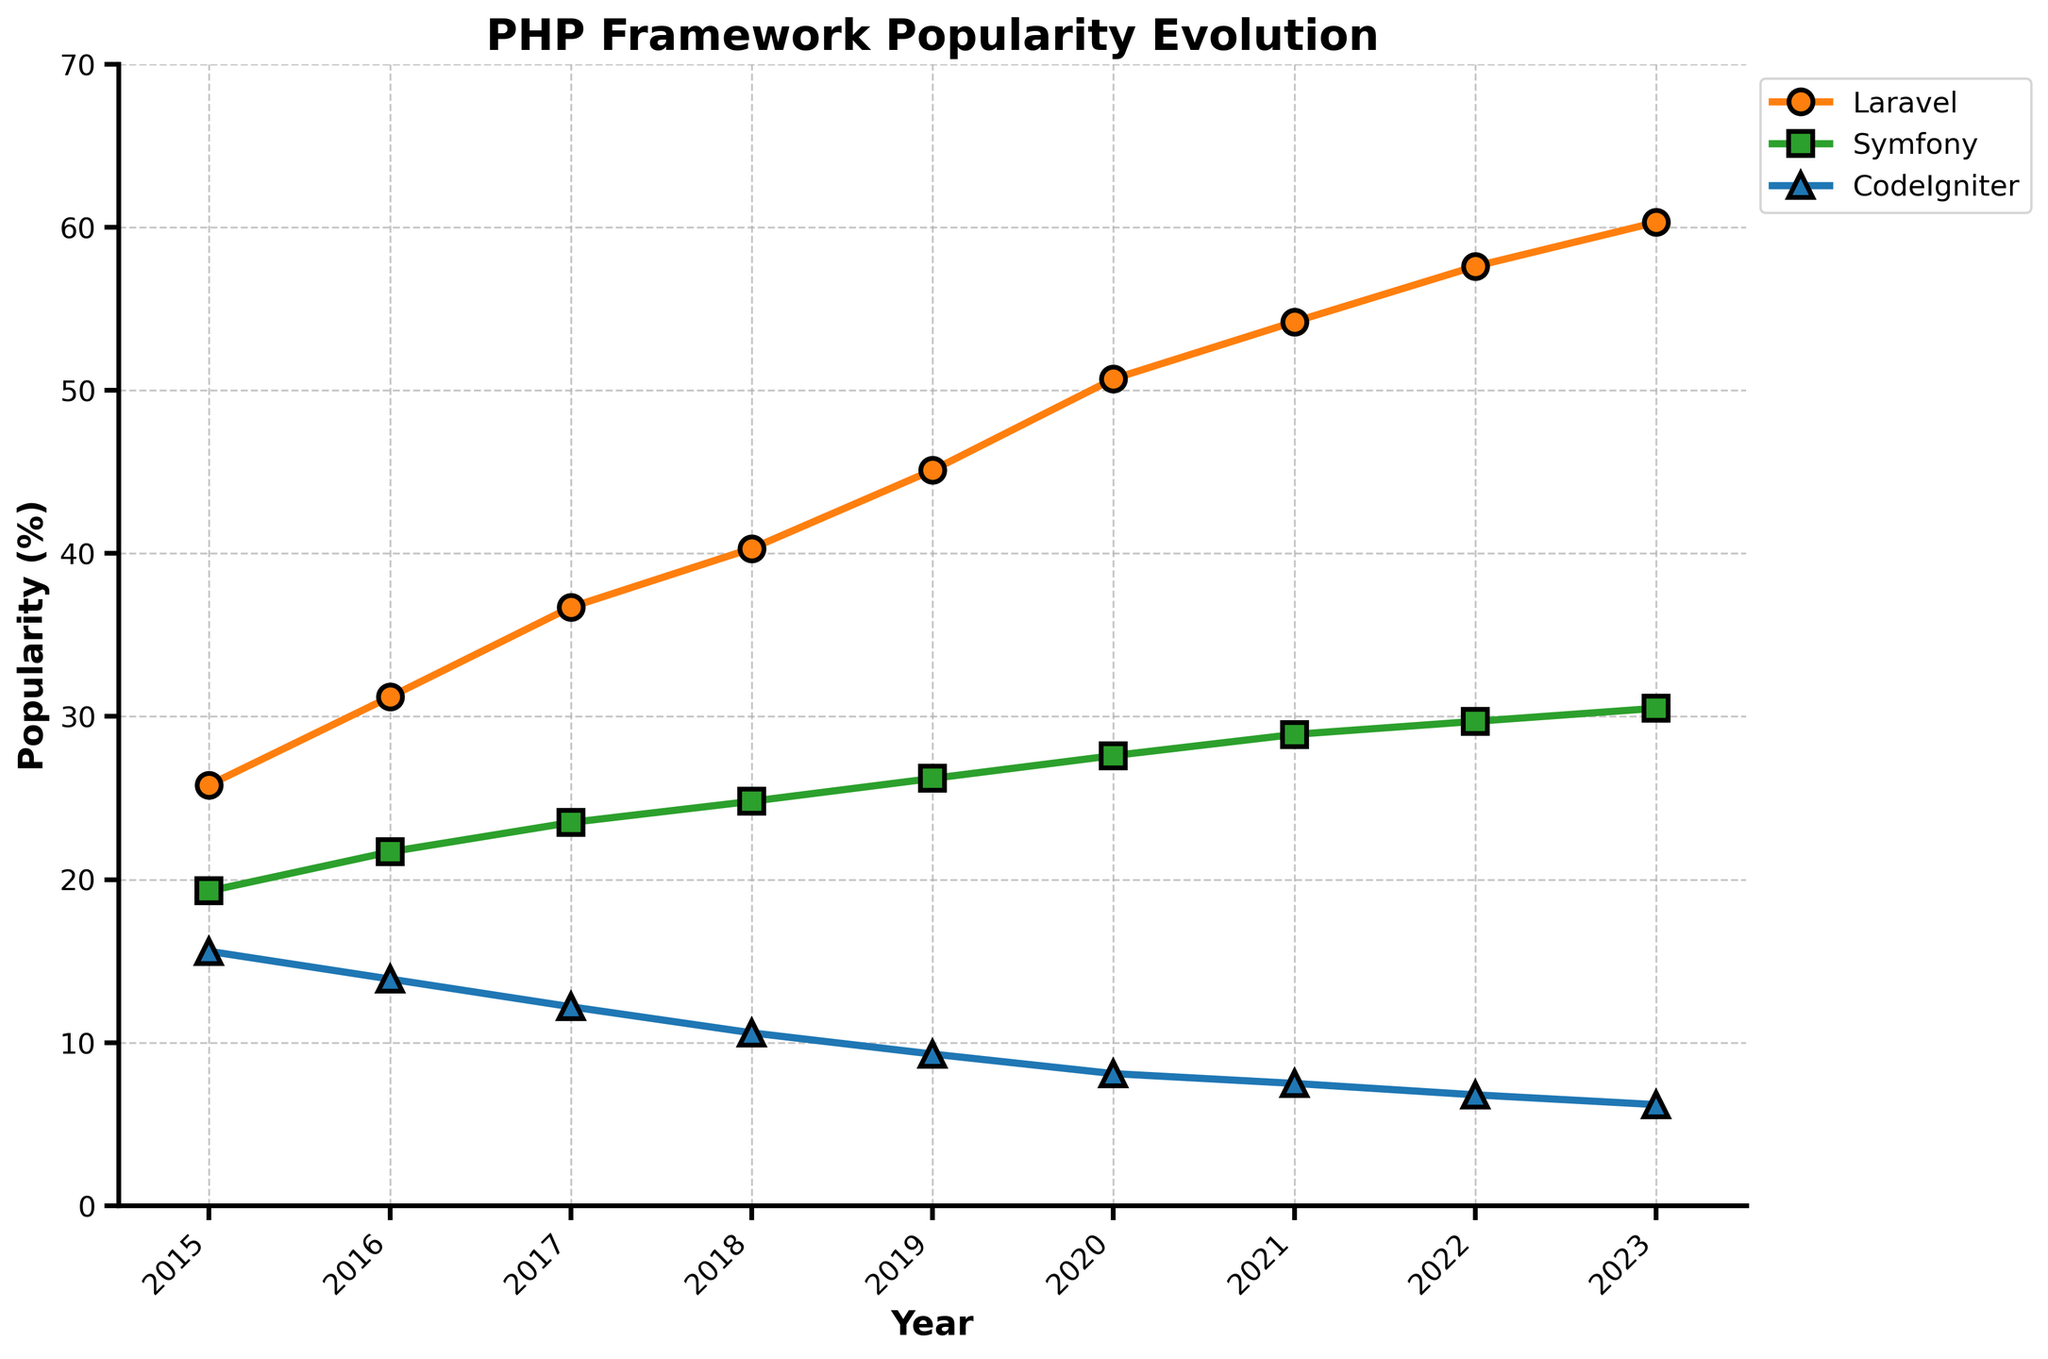What year did Laravel first surpass 50% popularity? By looking at the line representing Laravel (orange with circle markers), we see that it crossed the 50% mark between 2019 and 2020. Specifically, in 2020, it reached 50.7%, surpassing the 50% threshold for the first time.
Answer: 2020 Which PHP framework had the lowest popularity in 2023? Observing the three lines at the 2023 data point, CodeIgniter (blue with triangle markers) is the lowest with 6.2% popularity compared to Laravel and Symfony.
Answer: CodeIgniter How much did Symfony's popularity change from 2016 to 2018? To determine the change, subtract Symfony’s popularity in 2016 (21.7%) from its popularity in 2018 (24.8%). 24.8% - 21.7% equals a change of 3.1%.
Answer: 3.1% By how much did Laravel's popularity increase from 2015 to 2023? Subtract Laravel’s popularity in 2015 (25.8%) from its popularity in 2023 (60.3%). The increase is 60.3% - 25.8% = 34.5%.
Answer: 34.5% Which framework shows the slowest rate of change from 2015 to 2023? By analyzing the slopes of the lines, Symfony (green with square markers) has the slowest increase over the years compared to the steeper inclines of Laravel and the decline of CodeIgniter.
Answer: Symfony In which year were all three frameworks closest in popularity? Check the points where the lines are closest together on the vertical axis. In 2015, Laravel, Symfony, and CodeIgniter had 25.8%, 19.3%, and 15.6% respectively, making the difference smallest between them compared to other years.
Answer: 2015 Estimate the average popularity of CodeIgniter over the years displayed. Add CodeIgniter's popularity percentages for all years and divide by the number of years: (15.6 + 13.9 + 12.2 + 10.6 + 9.3 + 8.1 + 7.5 + 6.8 + 6.2) / 9 = 10.0%.
Answer: 10.0% What visual attribute differentiates the lines representing Laravel, Symfony, and CodeIgniter? Laravel is an orange line with circle markers, Symfony is a green line with square markers, and CodeIgniter is a blue line with triangle markers. These color and marker shape differences help in distinguishing the three lines.
Answer: Color and marker shape Which two frameworks experienced opposite trends in popularity from 2015 to 2023? Laravel (orange with circle markers) shows an upward trend whereas CodeIgniter (blue with triangle markers) shows a downward trend throughout the years from 2015 to 2023, making them oppositely trending frameworks.
Answer: Laravel and CodeIgniter 